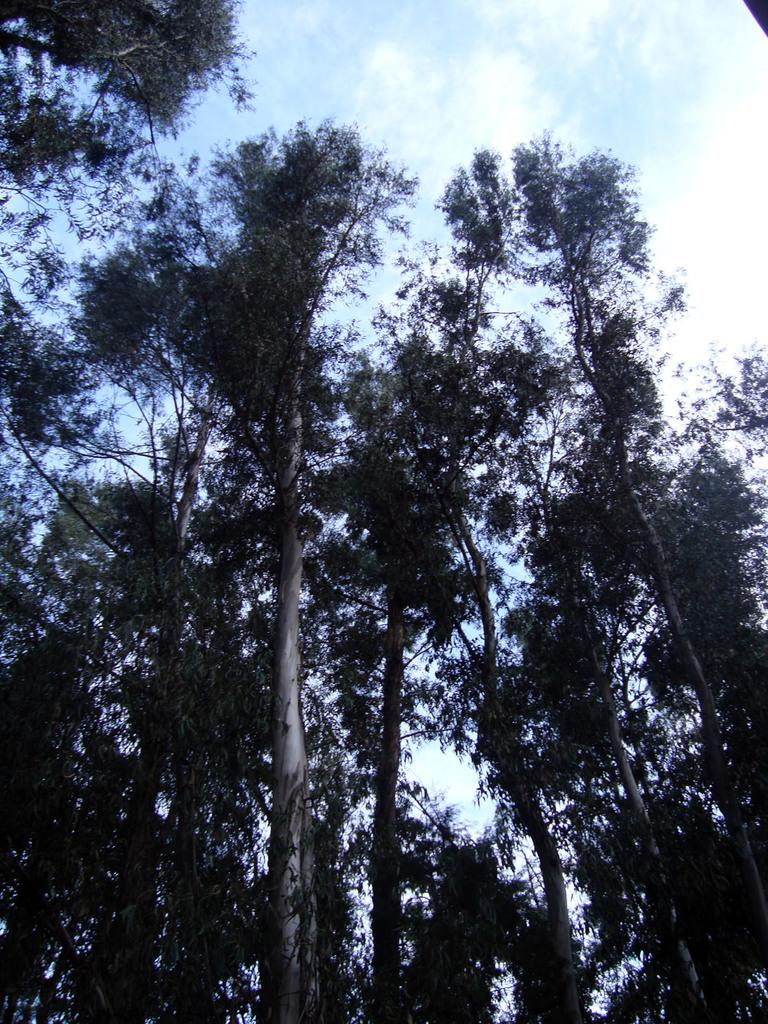What type of vegetation can be seen in the image? There are trees in the image. What is visible in the background of the image? The sky is visible in the image. What can be seen in the sky? Clouds are present in the sky. What type of shoes can be seen hanging from the trees in the image? There are no shoes present in the image; it only features trees and clouds in the sky. 